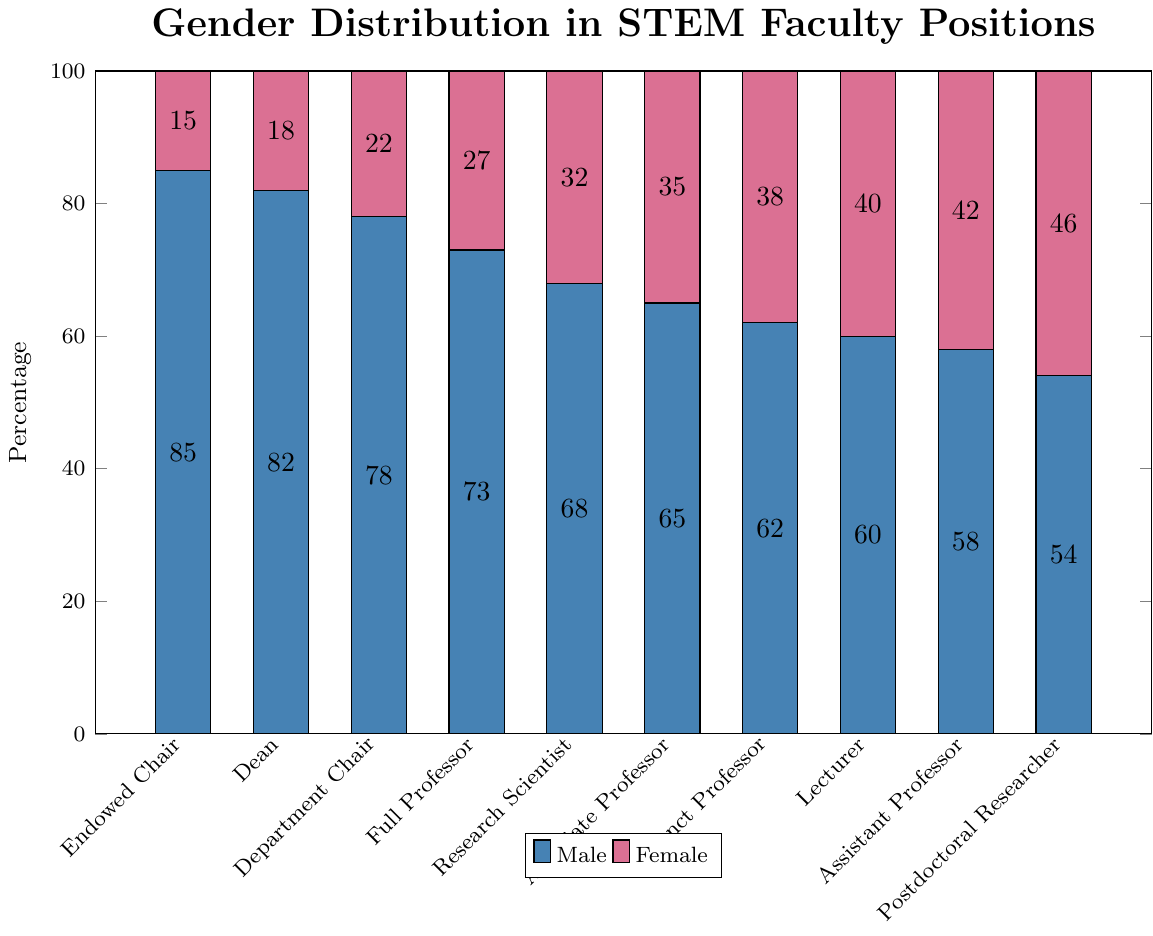What position has the highest percentage of females? Identify the bar that is highlighted in pink and has the tallest height among all positions. The position associated with this bar will have the highest percentage of females.
Answer: Postdoctoral Researcher Which position has a greater proportion of males, Department Chair or Full Professor? Compare the heights of the blue bars for Department Chair and Full Professor. The taller blue bar indicates a higher percentage of males.
Answer: Department Chair What is the difference in percentage points between male and female Research Scientists? Subtract the height of the pink bar for Research Scientist from the height of the blue bar for Research Scientist.
Answer: 36 If you sum the percentages of females in the Dean and Lecturer positions, what do you get? Add the heights of the pink bars for Dean and Lecturer.
Answer: 58 Which two positions have the closest gender distribution? Assess which pairs of blue and pink bars have similar heights, indicating a closer distribution between genders.
Answer: Postdoctoral Researcher and Assistant Professor How many positions have at least 40% females? Count the number of pink bars that have a height of 40 or more.
Answer: 3 What is the visual color used to represent male percentages in the chart? Identify the color used for the taller bars in each pair of bar groups.
Answer: Blue By how many percentage points do males in the Adjunct Professor position exceed females? Subtract the height of the pink bar for Adjunct Professor from the height of the blue bar for Adjunct Professor.
Answer: 24 Which position has the smallest gender gap between males and females? Identify the bars where the difference in heights between the blue and pink bars is the smallest.
Answer: Postdoctoral Researcher How does the percentage of females in Assistant Professor positions compare to that in Associate Professor positions? Compare the height of the pink bars in Assistant Professor and Associate Professor.
Answer: Higher in Assistant Professor 